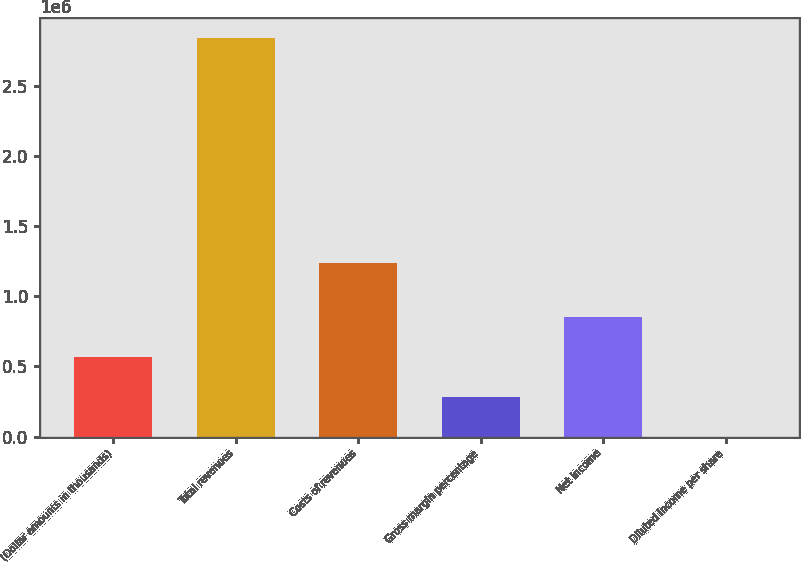Convert chart to OTSL. <chart><loc_0><loc_0><loc_500><loc_500><bar_chart><fcel>(Dollar amounts in thousands)<fcel>Total revenues<fcel>Costs of revenues<fcel>Gross margin percentage<fcel>Net income<fcel>Diluted income per share<nl><fcel>568559<fcel>2.84278e+06<fcel>1.23745e+06<fcel>284281<fcel>852837<fcel>3.21<nl></chart> 